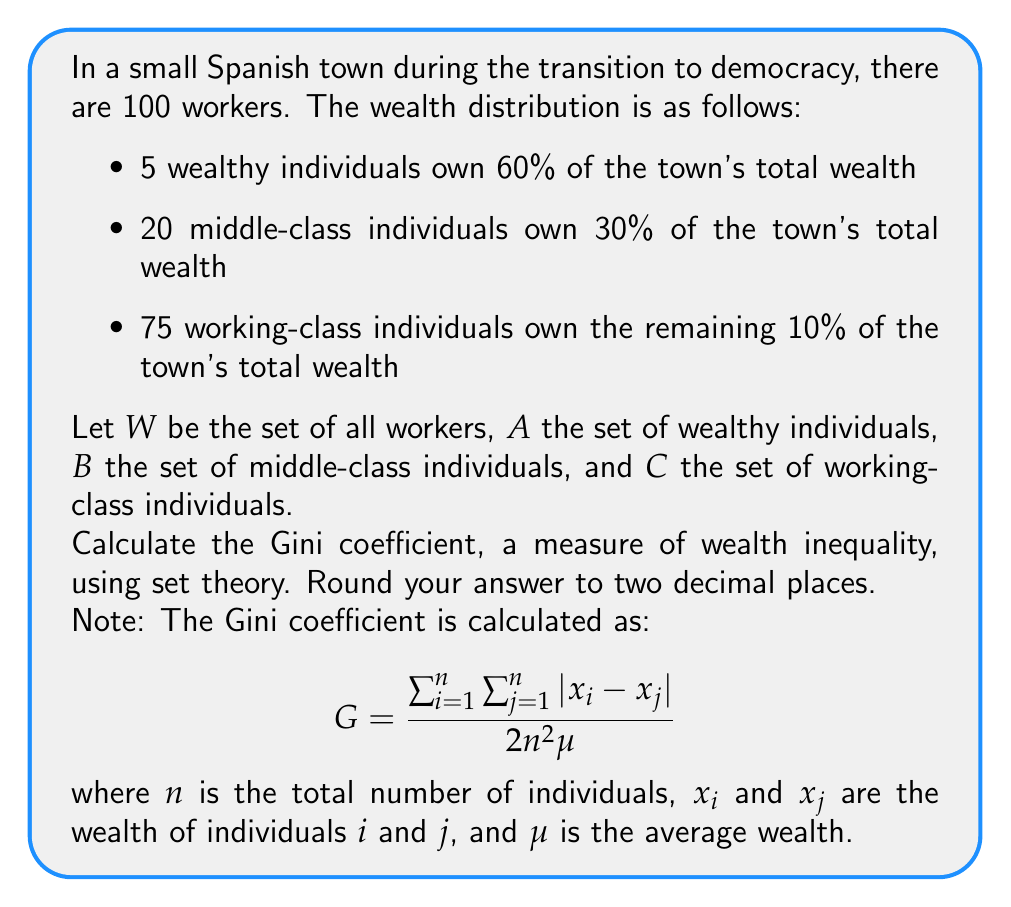Give your solution to this math problem. To solve this problem, we'll follow these steps:

1. Define the sets and their cardinalities:
   $|W| = 100$, $|A| = 5$, $|B| = 20$, $|C| = 75$

2. Calculate the average wealth $\mu$:
   Total wealth = 100%, so $\mu = 1\%$

3. Calculate individual wealth:
   - For $i \in A$: $x_i = \frac{60\%}{5} = 12\%$
   - For $i \in B$: $x_i = \frac{30\%}{20} = 1.5\%$
   - For $i \in C$: $x_i = \frac{10\%}{75} \approx 0.1333\%$

4. Calculate $\sum_{i=1}^n \sum_{j=1}^n |x_i - x_j|$:

   $$ \begin{align*}
   &= |A| \cdot |B| \cdot |12\% - 1.5\%| + |A| \cdot |C| \cdot |12\% - 0.1333\%| \\
   &+ |B| \cdot |C| \cdot |1.5\% - 0.1333\%| + |A| \cdot (|A|-1) \cdot |12\% - 12\%| \\
   &+ |B| \cdot (|B|-1) \cdot |1.5\% - 1.5\%| + |C| \cdot (|C|-1) \cdot |0.1333\% - 0.1333\%| \\
   &= 5 \cdot 20 \cdot 10.5\% + 5 \cdot 75 \cdot 11.8667\% + 20 \cdot 75 \cdot 1.3667\% \\
   &+ 5 \cdot 4 \cdot 0\% + 20 \cdot 19 \cdot 0\% + 75 \cdot 74 \cdot 0\% \\
   &= 1050\% + 4450.0125\% + 2050.05\% \\
   &= 7550.0625\%
   \end{align*} $$

5. Apply the Gini coefficient formula:

   $$ G = \frac{7550.0625\%}{2 \cdot 100^2 \cdot 1\%} = \frac{7550.0625}{20000} = 0.37750312 $$

6. Round to two decimal places: 0.38
Answer: The Gini coefficient for the wealth distribution in the Spanish town is 0.38. 